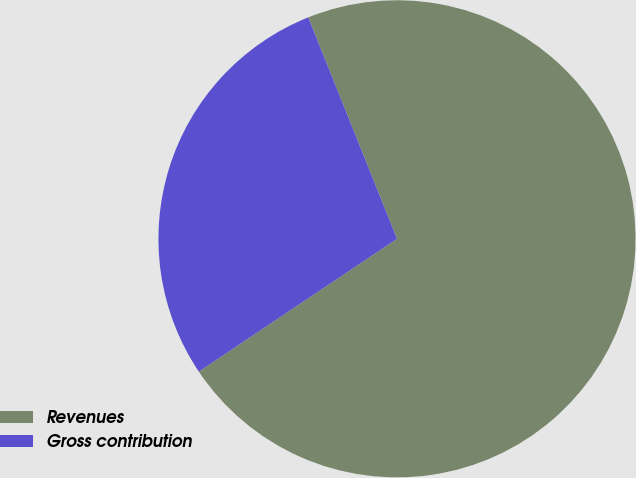Convert chart. <chart><loc_0><loc_0><loc_500><loc_500><pie_chart><fcel>Revenues<fcel>Gross contribution<nl><fcel>71.67%<fcel>28.33%<nl></chart> 